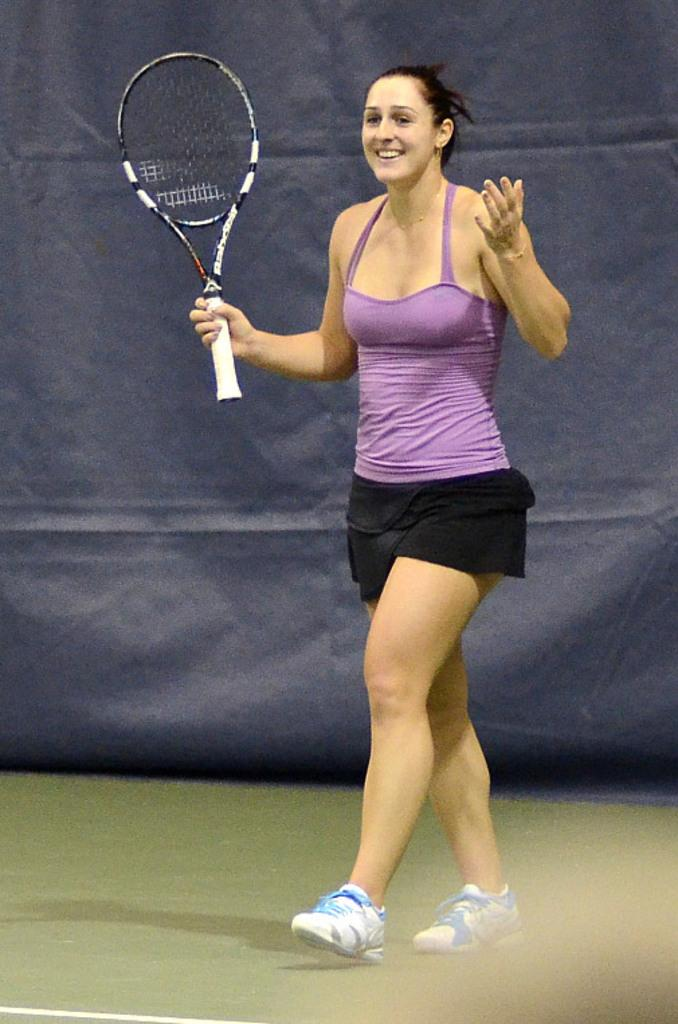Who is the main subject in the image? There is a woman in the image. What is the woman doing in the image? The woman is standing and holding a tennis racket in her hand. What can be seen in the background of the image? There is an ash-colored cloth in the background of the image. What type of corn is growing in the image? There is no corn present in the image. Can you tell me how many points the woman has scored in the game? The image does not show the woman playing a game or scoring points, so it cannot be determined from the image. 